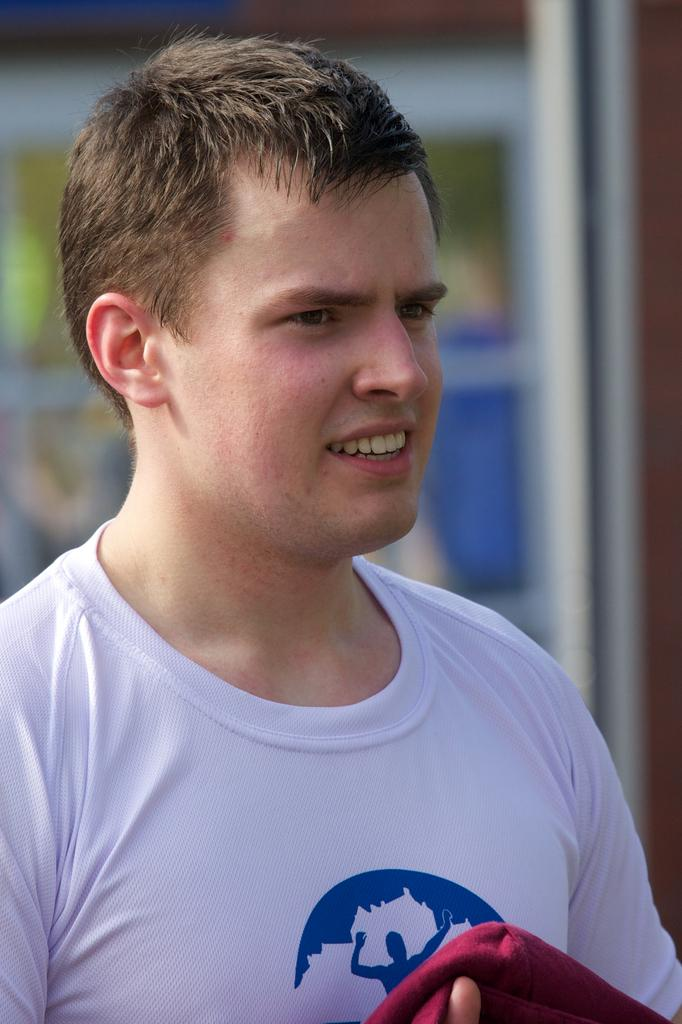Who or what is the main subject in the image? There is a person in the image. What is the person wearing? The person is wearing a white top. What is the person holding in the image? The person is holding a cloth. Can you describe the background of the image? The background of the image is blurry. What type of square object can be seen on the person's head in the image? There is no square object visible on the person's head in the image. 